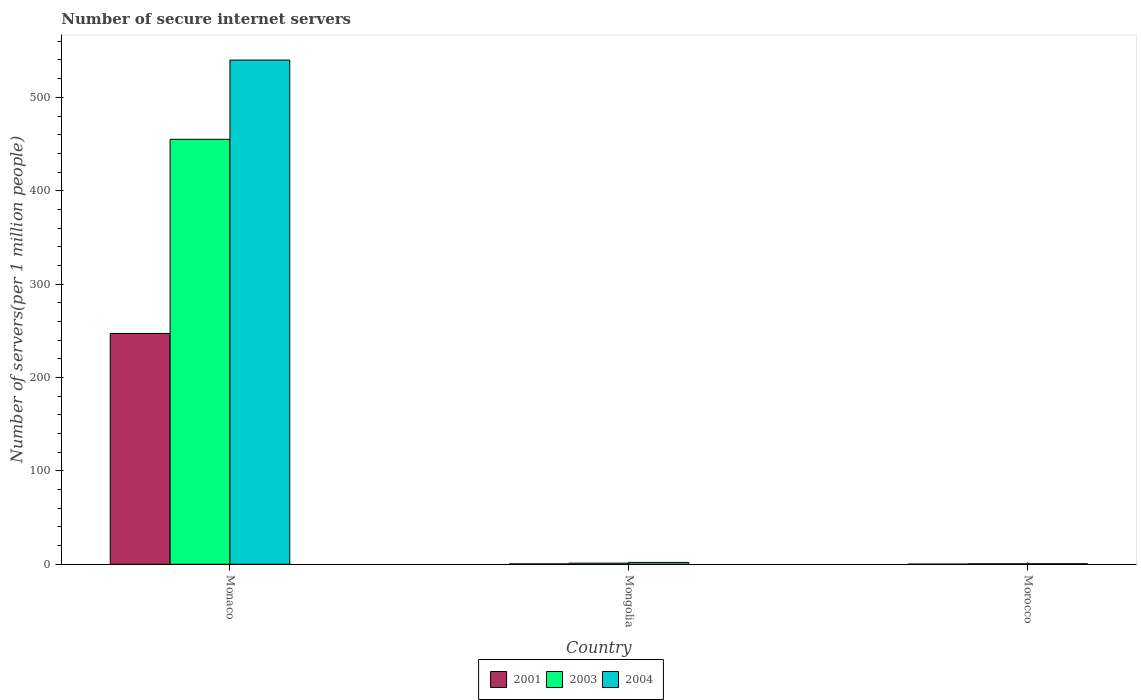How many different coloured bars are there?
Provide a succinct answer. 3. How many bars are there on the 2nd tick from the left?
Make the answer very short. 3. What is the label of the 1st group of bars from the left?
Make the answer very short. Monaco. What is the number of secure internet servers in 2004 in Morocco?
Provide a short and direct response. 0.56. Across all countries, what is the maximum number of secure internet servers in 2004?
Ensure brevity in your answer.  539.91. Across all countries, what is the minimum number of secure internet servers in 2001?
Your answer should be compact. 0.17. In which country was the number of secure internet servers in 2004 maximum?
Make the answer very short. Monaco. In which country was the number of secure internet servers in 2001 minimum?
Provide a succinct answer. Morocco. What is the total number of secure internet servers in 2003 in the graph?
Your answer should be very brief. 456.82. What is the difference between the number of secure internet servers in 2004 in Mongolia and that in Morocco?
Provide a succinct answer. 1.44. What is the difference between the number of secure internet servers in 2004 in Monaco and the number of secure internet servers in 2001 in Mongolia?
Ensure brevity in your answer.  539.49. What is the average number of secure internet servers in 2004 per country?
Your response must be concise. 180.83. What is the difference between the number of secure internet servers of/in 2001 and number of secure internet servers of/in 2003 in Mongolia?
Offer a terse response. -0.8. In how many countries, is the number of secure internet servers in 2004 greater than 520?
Provide a succinct answer. 1. What is the ratio of the number of secure internet servers in 2004 in Mongolia to that in Morocco?
Provide a succinct answer. 3.55. Is the number of secure internet servers in 2001 in Monaco less than that in Mongolia?
Keep it short and to the point. No. Is the difference between the number of secure internet servers in 2001 in Mongolia and Morocco greater than the difference between the number of secure internet servers in 2003 in Mongolia and Morocco?
Your answer should be very brief. No. What is the difference between the highest and the second highest number of secure internet servers in 2003?
Give a very brief answer. -0.71. What is the difference between the highest and the lowest number of secure internet servers in 2003?
Offer a terse response. 454.59. Is the sum of the number of secure internet servers in 2004 in Monaco and Mongolia greater than the maximum number of secure internet servers in 2003 across all countries?
Keep it short and to the point. Yes. What does the 3rd bar from the left in Morocco represents?
Make the answer very short. 2004. How many bars are there?
Your answer should be compact. 9. Are all the bars in the graph horizontal?
Offer a very short reply. No. What is the difference between two consecutive major ticks on the Y-axis?
Offer a very short reply. 100. Are the values on the major ticks of Y-axis written in scientific E-notation?
Provide a succinct answer. No. What is the title of the graph?
Give a very brief answer. Number of secure internet servers. What is the label or title of the X-axis?
Your response must be concise. Country. What is the label or title of the Y-axis?
Provide a succinct answer. Number of servers(per 1 million people). What is the Number of servers(per 1 million people) in 2001 in Monaco?
Your answer should be compact. 247.19. What is the Number of servers(per 1 million people) of 2003 in Monaco?
Your answer should be very brief. 455.1. What is the Number of servers(per 1 million people) in 2004 in Monaco?
Keep it short and to the point. 539.91. What is the Number of servers(per 1 million people) in 2001 in Mongolia?
Keep it short and to the point. 0.41. What is the Number of servers(per 1 million people) of 2003 in Mongolia?
Provide a succinct answer. 1.22. What is the Number of servers(per 1 million people) in 2004 in Mongolia?
Give a very brief answer. 2. What is the Number of servers(per 1 million people) in 2001 in Morocco?
Your response must be concise. 0.17. What is the Number of servers(per 1 million people) in 2003 in Morocco?
Your answer should be compact. 0.5. What is the Number of servers(per 1 million people) in 2004 in Morocco?
Provide a succinct answer. 0.56. Across all countries, what is the maximum Number of servers(per 1 million people) in 2001?
Provide a succinct answer. 247.19. Across all countries, what is the maximum Number of servers(per 1 million people) in 2003?
Offer a very short reply. 455.1. Across all countries, what is the maximum Number of servers(per 1 million people) in 2004?
Offer a terse response. 539.91. Across all countries, what is the minimum Number of servers(per 1 million people) in 2001?
Your answer should be compact. 0.17. Across all countries, what is the minimum Number of servers(per 1 million people) in 2003?
Offer a terse response. 0.5. Across all countries, what is the minimum Number of servers(per 1 million people) of 2004?
Offer a very short reply. 0.56. What is the total Number of servers(per 1 million people) of 2001 in the graph?
Give a very brief answer. 247.77. What is the total Number of servers(per 1 million people) of 2003 in the graph?
Keep it short and to the point. 456.82. What is the total Number of servers(per 1 million people) of 2004 in the graph?
Your answer should be very brief. 542.48. What is the difference between the Number of servers(per 1 million people) of 2001 in Monaco and that in Mongolia?
Your answer should be compact. 246.78. What is the difference between the Number of servers(per 1 million people) in 2003 in Monaco and that in Mongolia?
Your answer should be very brief. 453.88. What is the difference between the Number of servers(per 1 million people) of 2004 in Monaco and that in Mongolia?
Your answer should be compact. 537.91. What is the difference between the Number of servers(per 1 million people) in 2001 in Monaco and that in Morocco?
Give a very brief answer. 247.02. What is the difference between the Number of servers(per 1 million people) of 2003 in Monaco and that in Morocco?
Provide a succinct answer. 454.59. What is the difference between the Number of servers(per 1 million people) in 2004 in Monaco and that in Morocco?
Provide a succinct answer. 539.34. What is the difference between the Number of servers(per 1 million people) in 2001 in Mongolia and that in Morocco?
Offer a terse response. 0.24. What is the difference between the Number of servers(per 1 million people) of 2003 in Mongolia and that in Morocco?
Ensure brevity in your answer.  0.71. What is the difference between the Number of servers(per 1 million people) of 2004 in Mongolia and that in Morocco?
Provide a succinct answer. 1.44. What is the difference between the Number of servers(per 1 million people) of 2001 in Monaco and the Number of servers(per 1 million people) of 2003 in Mongolia?
Ensure brevity in your answer.  245.97. What is the difference between the Number of servers(per 1 million people) of 2001 in Monaco and the Number of servers(per 1 million people) of 2004 in Mongolia?
Your answer should be compact. 245.19. What is the difference between the Number of servers(per 1 million people) of 2003 in Monaco and the Number of servers(per 1 million people) of 2004 in Mongolia?
Give a very brief answer. 453.09. What is the difference between the Number of servers(per 1 million people) in 2001 in Monaco and the Number of servers(per 1 million people) in 2003 in Morocco?
Keep it short and to the point. 246.69. What is the difference between the Number of servers(per 1 million people) of 2001 in Monaco and the Number of servers(per 1 million people) of 2004 in Morocco?
Your response must be concise. 246.62. What is the difference between the Number of servers(per 1 million people) of 2003 in Monaco and the Number of servers(per 1 million people) of 2004 in Morocco?
Keep it short and to the point. 454.53. What is the difference between the Number of servers(per 1 million people) in 2001 in Mongolia and the Number of servers(per 1 million people) in 2003 in Morocco?
Make the answer very short. -0.09. What is the difference between the Number of servers(per 1 million people) of 2001 in Mongolia and the Number of servers(per 1 million people) of 2004 in Morocco?
Offer a very short reply. -0.15. What is the difference between the Number of servers(per 1 million people) in 2003 in Mongolia and the Number of servers(per 1 million people) in 2004 in Morocco?
Ensure brevity in your answer.  0.65. What is the average Number of servers(per 1 million people) in 2001 per country?
Your response must be concise. 82.59. What is the average Number of servers(per 1 million people) of 2003 per country?
Give a very brief answer. 152.27. What is the average Number of servers(per 1 million people) of 2004 per country?
Provide a succinct answer. 180.83. What is the difference between the Number of servers(per 1 million people) of 2001 and Number of servers(per 1 million people) of 2003 in Monaco?
Offer a terse response. -207.91. What is the difference between the Number of servers(per 1 million people) of 2001 and Number of servers(per 1 million people) of 2004 in Monaco?
Your answer should be compact. -292.72. What is the difference between the Number of servers(per 1 million people) in 2003 and Number of servers(per 1 million people) in 2004 in Monaco?
Make the answer very short. -84.81. What is the difference between the Number of servers(per 1 million people) in 2001 and Number of servers(per 1 million people) in 2003 in Mongolia?
Offer a terse response. -0.8. What is the difference between the Number of servers(per 1 million people) of 2001 and Number of servers(per 1 million people) of 2004 in Mongolia?
Ensure brevity in your answer.  -1.59. What is the difference between the Number of servers(per 1 million people) of 2003 and Number of servers(per 1 million people) of 2004 in Mongolia?
Ensure brevity in your answer.  -0.79. What is the difference between the Number of servers(per 1 million people) of 2001 and Number of servers(per 1 million people) of 2003 in Morocco?
Your answer should be compact. -0.33. What is the difference between the Number of servers(per 1 million people) in 2001 and Number of servers(per 1 million people) in 2004 in Morocco?
Offer a terse response. -0.39. What is the difference between the Number of servers(per 1 million people) of 2003 and Number of servers(per 1 million people) of 2004 in Morocco?
Offer a terse response. -0.06. What is the ratio of the Number of servers(per 1 million people) in 2001 in Monaco to that in Mongolia?
Your response must be concise. 598.13. What is the ratio of the Number of servers(per 1 million people) in 2003 in Monaco to that in Mongolia?
Your answer should be very brief. 374.55. What is the ratio of the Number of servers(per 1 million people) in 2004 in Monaco to that in Mongolia?
Your response must be concise. 269.59. What is the ratio of the Number of servers(per 1 million people) of 2001 in Monaco to that in Morocco?
Offer a very short reply. 1446.1. What is the ratio of the Number of servers(per 1 million people) of 2003 in Monaco to that in Morocco?
Make the answer very short. 904.51. What is the ratio of the Number of servers(per 1 million people) of 2004 in Monaco to that in Morocco?
Offer a terse response. 955.74. What is the ratio of the Number of servers(per 1 million people) in 2001 in Mongolia to that in Morocco?
Offer a terse response. 2.42. What is the ratio of the Number of servers(per 1 million people) in 2003 in Mongolia to that in Morocco?
Your answer should be compact. 2.41. What is the ratio of the Number of servers(per 1 million people) of 2004 in Mongolia to that in Morocco?
Your answer should be very brief. 3.55. What is the difference between the highest and the second highest Number of servers(per 1 million people) in 2001?
Ensure brevity in your answer.  246.78. What is the difference between the highest and the second highest Number of servers(per 1 million people) in 2003?
Provide a short and direct response. 453.88. What is the difference between the highest and the second highest Number of servers(per 1 million people) in 2004?
Offer a terse response. 537.91. What is the difference between the highest and the lowest Number of servers(per 1 million people) of 2001?
Your response must be concise. 247.02. What is the difference between the highest and the lowest Number of servers(per 1 million people) in 2003?
Your answer should be compact. 454.59. What is the difference between the highest and the lowest Number of servers(per 1 million people) in 2004?
Provide a short and direct response. 539.34. 